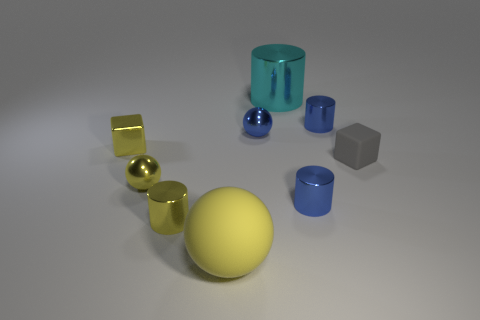What size is the block that is to the right of the large object that is behind the metal cylinder that is left of the blue ball?
Keep it short and to the point. Small. Are the yellow block and the tiny cylinder left of the big metallic cylinder made of the same material?
Your answer should be very brief. Yes. There is a cyan object that is the same material as the yellow cylinder; what is its size?
Your response must be concise. Large. Are there any small things of the same shape as the large metal object?
Ensure brevity in your answer.  Yes. What number of things are spheres that are behind the big yellow object or small yellow metallic cylinders?
Provide a succinct answer. 3. What size is the matte thing that is the same color as the metallic block?
Your answer should be very brief. Large. There is a small cylinder that is behind the yellow shiny block; is it the same color as the small sphere behind the rubber cube?
Your answer should be compact. Yes. How big is the yellow matte sphere?
Provide a succinct answer. Large. What number of small things are either blue balls or yellow cylinders?
Provide a succinct answer. 2. There is a shiny cylinder that is the same size as the yellow matte object; what is its color?
Offer a very short reply. Cyan. 